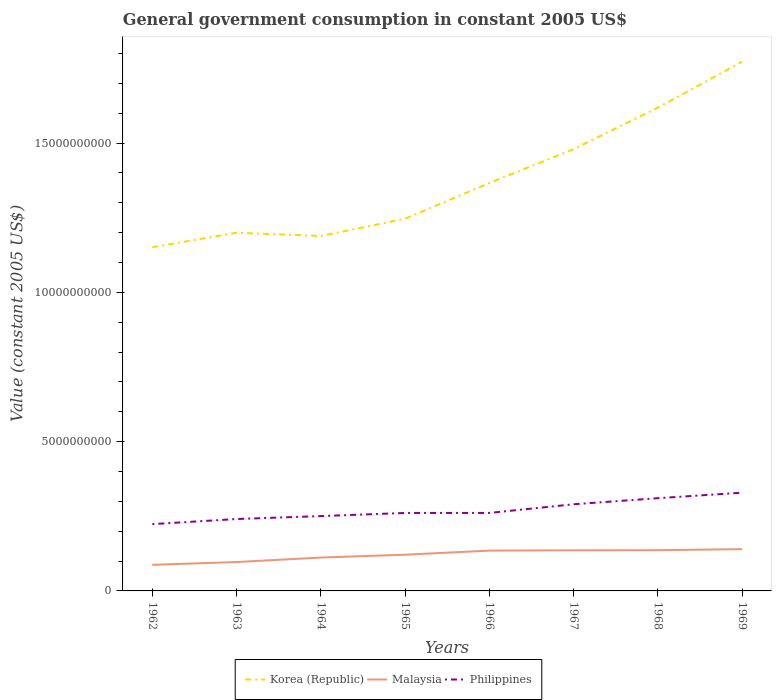How many different coloured lines are there?
Your response must be concise. 3. Is the number of lines equal to the number of legend labels?
Offer a very short reply. Yes. Across all years, what is the maximum government conusmption in Korea (Republic)?
Offer a terse response. 1.15e+1. What is the total government conusmption in Korea (Republic) in the graph?
Your response must be concise. -2.52e+09. What is the difference between the highest and the second highest government conusmption in Malaysia?
Provide a succinct answer. 5.26e+08. What is the difference between the highest and the lowest government conusmption in Korea (Republic)?
Make the answer very short. 3. How many years are there in the graph?
Make the answer very short. 8. What is the difference between two consecutive major ticks on the Y-axis?
Ensure brevity in your answer.  5.00e+09. Does the graph contain grids?
Provide a short and direct response. No. How many legend labels are there?
Ensure brevity in your answer.  3. What is the title of the graph?
Your answer should be compact. General government consumption in constant 2005 US$. What is the label or title of the X-axis?
Your response must be concise. Years. What is the label or title of the Y-axis?
Make the answer very short. Value (constant 2005 US$). What is the Value (constant 2005 US$) of Korea (Republic) in 1962?
Your answer should be compact. 1.15e+1. What is the Value (constant 2005 US$) of Malaysia in 1962?
Offer a very short reply. 8.74e+08. What is the Value (constant 2005 US$) in Philippines in 1962?
Your answer should be very brief. 2.24e+09. What is the Value (constant 2005 US$) of Korea (Republic) in 1963?
Give a very brief answer. 1.20e+1. What is the Value (constant 2005 US$) of Malaysia in 1963?
Offer a very short reply. 9.68e+08. What is the Value (constant 2005 US$) in Philippines in 1963?
Make the answer very short. 2.41e+09. What is the Value (constant 2005 US$) of Korea (Republic) in 1964?
Offer a terse response. 1.19e+1. What is the Value (constant 2005 US$) of Malaysia in 1964?
Provide a succinct answer. 1.12e+09. What is the Value (constant 2005 US$) in Philippines in 1964?
Make the answer very short. 2.51e+09. What is the Value (constant 2005 US$) of Korea (Republic) in 1965?
Your answer should be very brief. 1.25e+1. What is the Value (constant 2005 US$) in Malaysia in 1965?
Your answer should be compact. 1.21e+09. What is the Value (constant 2005 US$) in Philippines in 1965?
Provide a short and direct response. 2.61e+09. What is the Value (constant 2005 US$) in Korea (Republic) in 1966?
Your answer should be compact. 1.37e+1. What is the Value (constant 2005 US$) of Malaysia in 1966?
Offer a very short reply. 1.35e+09. What is the Value (constant 2005 US$) of Philippines in 1966?
Give a very brief answer. 2.61e+09. What is the Value (constant 2005 US$) in Korea (Republic) in 1967?
Provide a short and direct response. 1.48e+1. What is the Value (constant 2005 US$) of Malaysia in 1967?
Your answer should be very brief. 1.36e+09. What is the Value (constant 2005 US$) in Philippines in 1967?
Your answer should be compact. 2.90e+09. What is the Value (constant 2005 US$) of Korea (Republic) in 1968?
Your answer should be compact. 1.62e+1. What is the Value (constant 2005 US$) in Malaysia in 1968?
Give a very brief answer. 1.36e+09. What is the Value (constant 2005 US$) of Philippines in 1968?
Offer a very short reply. 3.11e+09. What is the Value (constant 2005 US$) in Korea (Republic) in 1969?
Keep it short and to the point. 1.77e+1. What is the Value (constant 2005 US$) of Malaysia in 1969?
Provide a short and direct response. 1.40e+09. What is the Value (constant 2005 US$) in Philippines in 1969?
Provide a short and direct response. 3.29e+09. Across all years, what is the maximum Value (constant 2005 US$) in Korea (Republic)?
Your answer should be compact. 1.77e+1. Across all years, what is the maximum Value (constant 2005 US$) of Malaysia?
Provide a succinct answer. 1.40e+09. Across all years, what is the maximum Value (constant 2005 US$) of Philippines?
Your response must be concise. 3.29e+09. Across all years, what is the minimum Value (constant 2005 US$) in Korea (Republic)?
Provide a succinct answer. 1.15e+1. Across all years, what is the minimum Value (constant 2005 US$) of Malaysia?
Offer a terse response. 8.74e+08. Across all years, what is the minimum Value (constant 2005 US$) of Philippines?
Keep it short and to the point. 2.24e+09. What is the total Value (constant 2005 US$) in Korea (Republic) in the graph?
Keep it short and to the point. 1.10e+11. What is the total Value (constant 2005 US$) in Malaysia in the graph?
Your answer should be very brief. 9.65e+09. What is the total Value (constant 2005 US$) in Philippines in the graph?
Your response must be concise. 2.17e+1. What is the difference between the Value (constant 2005 US$) of Korea (Republic) in 1962 and that in 1963?
Offer a terse response. -4.85e+08. What is the difference between the Value (constant 2005 US$) in Malaysia in 1962 and that in 1963?
Offer a very short reply. -9.39e+07. What is the difference between the Value (constant 2005 US$) in Philippines in 1962 and that in 1963?
Keep it short and to the point. -1.72e+08. What is the difference between the Value (constant 2005 US$) in Korea (Republic) in 1962 and that in 1964?
Your answer should be compact. -3.76e+08. What is the difference between the Value (constant 2005 US$) of Malaysia in 1962 and that in 1964?
Give a very brief answer. -2.44e+08. What is the difference between the Value (constant 2005 US$) of Philippines in 1962 and that in 1964?
Make the answer very short. -2.69e+08. What is the difference between the Value (constant 2005 US$) in Korea (Republic) in 1962 and that in 1965?
Make the answer very short. -9.53e+08. What is the difference between the Value (constant 2005 US$) in Malaysia in 1962 and that in 1965?
Provide a short and direct response. -3.39e+08. What is the difference between the Value (constant 2005 US$) of Philippines in 1962 and that in 1965?
Offer a terse response. -3.74e+08. What is the difference between the Value (constant 2005 US$) in Korea (Republic) in 1962 and that in 1966?
Provide a short and direct response. -2.15e+09. What is the difference between the Value (constant 2005 US$) of Malaysia in 1962 and that in 1966?
Offer a terse response. -4.76e+08. What is the difference between the Value (constant 2005 US$) of Philippines in 1962 and that in 1966?
Offer a terse response. -3.75e+08. What is the difference between the Value (constant 2005 US$) of Korea (Republic) in 1962 and that in 1967?
Keep it short and to the point. -3.28e+09. What is the difference between the Value (constant 2005 US$) in Malaysia in 1962 and that in 1967?
Give a very brief answer. -4.87e+08. What is the difference between the Value (constant 2005 US$) of Philippines in 1962 and that in 1967?
Offer a terse response. -6.65e+08. What is the difference between the Value (constant 2005 US$) in Korea (Republic) in 1962 and that in 1968?
Provide a succinct answer. -4.67e+09. What is the difference between the Value (constant 2005 US$) of Malaysia in 1962 and that in 1968?
Make the answer very short. -4.90e+08. What is the difference between the Value (constant 2005 US$) in Philippines in 1962 and that in 1968?
Your answer should be compact. -8.69e+08. What is the difference between the Value (constant 2005 US$) of Korea (Republic) in 1962 and that in 1969?
Ensure brevity in your answer.  -6.21e+09. What is the difference between the Value (constant 2005 US$) of Malaysia in 1962 and that in 1969?
Keep it short and to the point. -5.26e+08. What is the difference between the Value (constant 2005 US$) of Philippines in 1962 and that in 1969?
Ensure brevity in your answer.  -1.05e+09. What is the difference between the Value (constant 2005 US$) in Korea (Republic) in 1963 and that in 1964?
Provide a short and direct response. 1.09e+08. What is the difference between the Value (constant 2005 US$) in Malaysia in 1963 and that in 1964?
Your answer should be very brief. -1.50e+08. What is the difference between the Value (constant 2005 US$) of Philippines in 1963 and that in 1964?
Give a very brief answer. -9.80e+07. What is the difference between the Value (constant 2005 US$) of Korea (Republic) in 1963 and that in 1965?
Keep it short and to the point. -4.68e+08. What is the difference between the Value (constant 2005 US$) of Malaysia in 1963 and that in 1965?
Your answer should be compact. -2.45e+08. What is the difference between the Value (constant 2005 US$) in Philippines in 1963 and that in 1965?
Provide a succinct answer. -2.03e+08. What is the difference between the Value (constant 2005 US$) in Korea (Republic) in 1963 and that in 1966?
Make the answer very short. -1.67e+09. What is the difference between the Value (constant 2005 US$) in Malaysia in 1963 and that in 1966?
Offer a terse response. -3.83e+08. What is the difference between the Value (constant 2005 US$) in Philippines in 1963 and that in 1966?
Provide a succinct answer. -2.04e+08. What is the difference between the Value (constant 2005 US$) in Korea (Republic) in 1963 and that in 1967?
Your answer should be very brief. -2.80e+09. What is the difference between the Value (constant 2005 US$) in Malaysia in 1963 and that in 1967?
Provide a succinct answer. -3.93e+08. What is the difference between the Value (constant 2005 US$) of Philippines in 1963 and that in 1967?
Ensure brevity in your answer.  -4.94e+08. What is the difference between the Value (constant 2005 US$) of Korea (Republic) in 1963 and that in 1968?
Your answer should be very brief. -4.19e+09. What is the difference between the Value (constant 2005 US$) of Malaysia in 1963 and that in 1968?
Your answer should be compact. -3.96e+08. What is the difference between the Value (constant 2005 US$) of Philippines in 1963 and that in 1968?
Offer a terse response. -6.97e+08. What is the difference between the Value (constant 2005 US$) in Korea (Republic) in 1963 and that in 1969?
Provide a succinct answer. -5.73e+09. What is the difference between the Value (constant 2005 US$) in Malaysia in 1963 and that in 1969?
Ensure brevity in your answer.  -4.32e+08. What is the difference between the Value (constant 2005 US$) of Philippines in 1963 and that in 1969?
Offer a terse response. -8.82e+08. What is the difference between the Value (constant 2005 US$) in Korea (Republic) in 1964 and that in 1965?
Your response must be concise. -5.77e+08. What is the difference between the Value (constant 2005 US$) in Malaysia in 1964 and that in 1965?
Provide a succinct answer. -9.55e+07. What is the difference between the Value (constant 2005 US$) in Philippines in 1964 and that in 1965?
Offer a very short reply. -1.05e+08. What is the difference between the Value (constant 2005 US$) of Korea (Republic) in 1964 and that in 1966?
Provide a succinct answer. -1.77e+09. What is the difference between the Value (constant 2005 US$) of Malaysia in 1964 and that in 1966?
Keep it short and to the point. -2.33e+08. What is the difference between the Value (constant 2005 US$) in Philippines in 1964 and that in 1966?
Provide a succinct answer. -1.06e+08. What is the difference between the Value (constant 2005 US$) in Korea (Republic) in 1964 and that in 1967?
Your response must be concise. -2.91e+09. What is the difference between the Value (constant 2005 US$) in Malaysia in 1964 and that in 1967?
Your answer should be compact. -2.43e+08. What is the difference between the Value (constant 2005 US$) in Philippines in 1964 and that in 1967?
Your answer should be very brief. -3.96e+08. What is the difference between the Value (constant 2005 US$) in Korea (Republic) in 1964 and that in 1968?
Ensure brevity in your answer.  -4.30e+09. What is the difference between the Value (constant 2005 US$) in Malaysia in 1964 and that in 1968?
Keep it short and to the point. -2.46e+08. What is the difference between the Value (constant 2005 US$) of Philippines in 1964 and that in 1968?
Give a very brief answer. -5.99e+08. What is the difference between the Value (constant 2005 US$) of Korea (Republic) in 1964 and that in 1969?
Your response must be concise. -5.84e+09. What is the difference between the Value (constant 2005 US$) in Malaysia in 1964 and that in 1969?
Your answer should be very brief. -2.82e+08. What is the difference between the Value (constant 2005 US$) of Philippines in 1964 and that in 1969?
Make the answer very short. -7.84e+08. What is the difference between the Value (constant 2005 US$) in Korea (Republic) in 1965 and that in 1966?
Make the answer very short. -1.20e+09. What is the difference between the Value (constant 2005 US$) in Malaysia in 1965 and that in 1966?
Your answer should be compact. -1.37e+08. What is the difference between the Value (constant 2005 US$) of Philippines in 1965 and that in 1966?
Offer a very short reply. -8.17e+05. What is the difference between the Value (constant 2005 US$) in Korea (Republic) in 1965 and that in 1967?
Provide a short and direct response. -2.33e+09. What is the difference between the Value (constant 2005 US$) in Malaysia in 1965 and that in 1967?
Your answer should be very brief. -1.47e+08. What is the difference between the Value (constant 2005 US$) in Philippines in 1965 and that in 1967?
Provide a short and direct response. -2.91e+08. What is the difference between the Value (constant 2005 US$) in Korea (Republic) in 1965 and that in 1968?
Give a very brief answer. -3.72e+09. What is the difference between the Value (constant 2005 US$) of Malaysia in 1965 and that in 1968?
Your answer should be compact. -1.50e+08. What is the difference between the Value (constant 2005 US$) in Philippines in 1965 and that in 1968?
Keep it short and to the point. -4.95e+08. What is the difference between the Value (constant 2005 US$) of Korea (Republic) in 1965 and that in 1969?
Keep it short and to the point. -5.26e+09. What is the difference between the Value (constant 2005 US$) in Malaysia in 1965 and that in 1969?
Your response must be concise. -1.87e+08. What is the difference between the Value (constant 2005 US$) of Philippines in 1965 and that in 1969?
Your answer should be compact. -6.79e+08. What is the difference between the Value (constant 2005 US$) in Korea (Republic) in 1966 and that in 1967?
Ensure brevity in your answer.  -1.13e+09. What is the difference between the Value (constant 2005 US$) of Malaysia in 1966 and that in 1967?
Ensure brevity in your answer.  -1.01e+07. What is the difference between the Value (constant 2005 US$) of Philippines in 1966 and that in 1967?
Your answer should be very brief. -2.90e+08. What is the difference between the Value (constant 2005 US$) of Korea (Republic) in 1966 and that in 1968?
Give a very brief answer. -2.52e+09. What is the difference between the Value (constant 2005 US$) of Malaysia in 1966 and that in 1968?
Your response must be concise. -1.33e+07. What is the difference between the Value (constant 2005 US$) of Philippines in 1966 and that in 1968?
Your answer should be very brief. -4.94e+08. What is the difference between the Value (constant 2005 US$) in Korea (Republic) in 1966 and that in 1969?
Your answer should be compact. -4.06e+09. What is the difference between the Value (constant 2005 US$) in Malaysia in 1966 and that in 1969?
Give a very brief answer. -4.96e+07. What is the difference between the Value (constant 2005 US$) in Philippines in 1966 and that in 1969?
Your answer should be compact. -6.78e+08. What is the difference between the Value (constant 2005 US$) in Korea (Republic) in 1967 and that in 1968?
Offer a very short reply. -1.39e+09. What is the difference between the Value (constant 2005 US$) in Malaysia in 1967 and that in 1968?
Your answer should be very brief. -3.20e+06. What is the difference between the Value (constant 2005 US$) of Philippines in 1967 and that in 1968?
Offer a terse response. -2.04e+08. What is the difference between the Value (constant 2005 US$) of Korea (Republic) in 1967 and that in 1969?
Give a very brief answer. -2.93e+09. What is the difference between the Value (constant 2005 US$) of Malaysia in 1967 and that in 1969?
Your response must be concise. -3.95e+07. What is the difference between the Value (constant 2005 US$) in Philippines in 1967 and that in 1969?
Your answer should be compact. -3.88e+08. What is the difference between the Value (constant 2005 US$) in Korea (Republic) in 1968 and that in 1969?
Provide a succinct answer. -1.54e+09. What is the difference between the Value (constant 2005 US$) in Malaysia in 1968 and that in 1969?
Offer a terse response. -3.63e+07. What is the difference between the Value (constant 2005 US$) of Philippines in 1968 and that in 1969?
Your response must be concise. -1.85e+08. What is the difference between the Value (constant 2005 US$) in Korea (Republic) in 1962 and the Value (constant 2005 US$) in Malaysia in 1963?
Offer a terse response. 1.05e+1. What is the difference between the Value (constant 2005 US$) in Korea (Republic) in 1962 and the Value (constant 2005 US$) in Philippines in 1963?
Offer a very short reply. 9.10e+09. What is the difference between the Value (constant 2005 US$) in Malaysia in 1962 and the Value (constant 2005 US$) in Philippines in 1963?
Give a very brief answer. -1.53e+09. What is the difference between the Value (constant 2005 US$) in Korea (Republic) in 1962 and the Value (constant 2005 US$) in Malaysia in 1964?
Offer a terse response. 1.04e+1. What is the difference between the Value (constant 2005 US$) in Korea (Republic) in 1962 and the Value (constant 2005 US$) in Philippines in 1964?
Offer a terse response. 9.01e+09. What is the difference between the Value (constant 2005 US$) in Malaysia in 1962 and the Value (constant 2005 US$) in Philippines in 1964?
Your answer should be very brief. -1.63e+09. What is the difference between the Value (constant 2005 US$) of Korea (Republic) in 1962 and the Value (constant 2005 US$) of Malaysia in 1965?
Your response must be concise. 1.03e+1. What is the difference between the Value (constant 2005 US$) of Korea (Republic) in 1962 and the Value (constant 2005 US$) of Philippines in 1965?
Your answer should be very brief. 8.90e+09. What is the difference between the Value (constant 2005 US$) in Malaysia in 1962 and the Value (constant 2005 US$) in Philippines in 1965?
Offer a very short reply. -1.74e+09. What is the difference between the Value (constant 2005 US$) in Korea (Republic) in 1962 and the Value (constant 2005 US$) in Malaysia in 1966?
Offer a very short reply. 1.02e+1. What is the difference between the Value (constant 2005 US$) of Korea (Republic) in 1962 and the Value (constant 2005 US$) of Philippines in 1966?
Provide a succinct answer. 8.90e+09. What is the difference between the Value (constant 2005 US$) of Malaysia in 1962 and the Value (constant 2005 US$) of Philippines in 1966?
Provide a succinct answer. -1.74e+09. What is the difference between the Value (constant 2005 US$) in Korea (Republic) in 1962 and the Value (constant 2005 US$) in Malaysia in 1967?
Provide a short and direct response. 1.02e+1. What is the difference between the Value (constant 2005 US$) in Korea (Republic) in 1962 and the Value (constant 2005 US$) in Philippines in 1967?
Ensure brevity in your answer.  8.61e+09. What is the difference between the Value (constant 2005 US$) in Malaysia in 1962 and the Value (constant 2005 US$) in Philippines in 1967?
Offer a terse response. -2.03e+09. What is the difference between the Value (constant 2005 US$) of Korea (Republic) in 1962 and the Value (constant 2005 US$) of Malaysia in 1968?
Offer a terse response. 1.01e+1. What is the difference between the Value (constant 2005 US$) of Korea (Republic) in 1962 and the Value (constant 2005 US$) of Philippines in 1968?
Provide a short and direct response. 8.41e+09. What is the difference between the Value (constant 2005 US$) of Malaysia in 1962 and the Value (constant 2005 US$) of Philippines in 1968?
Your answer should be very brief. -2.23e+09. What is the difference between the Value (constant 2005 US$) in Korea (Republic) in 1962 and the Value (constant 2005 US$) in Malaysia in 1969?
Ensure brevity in your answer.  1.01e+1. What is the difference between the Value (constant 2005 US$) of Korea (Republic) in 1962 and the Value (constant 2005 US$) of Philippines in 1969?
Offer a very short reply. 8.22e+09. What is the difference between the Value (constant 2005 US$) in Malaysia in 1962 and the Value (constant 2005 US$) in Philippines in 1969?
Keep it short and to the point. -2.42e+09. What is the difference between the Value (constant 2005 US$) in Korea (Republic) in 1963 and the Value (constant 2005 US$) in Malaysia in 1964?
Offer a very short reply. 1.09e+1. What is the difference between the Value (constant 2005 US$) of Korea (Republic) in 1963 and the Value (constant 2005 US$) of Philippines in 1964?
Provide a short and direct response. 9.49e+09. What is the difference between the Value (constant 2005 US$) of Malaysia in 1963 and the Value (constant 2005 US$) of Philippines in 1964?
Your response must be concise. -1.54e+09. What is the difference between the Value (constant 2005 US$) in Korea (Republic) in 1963 and the Value (constant 2005 US$) in Malaysia in 1965?
Your answer should be very brief. 1.08e+1. What is the difference between the Value (constant 2005 US$) of Korea (Republic) in 1963 and the Value (constant 2005 US$) of Philippines in 1965?
Give a very brief answer. 9.39e+09. What is the difference between the Value (constant 2005 US$) of Malaysia in 1963 and the Value (constant 2005 US$) of Philippines in 1965?
Keep it short and to the point. -1.64e+09. What is the difference between the Value (constant 2005 US$) in Korea (Republic) in 1963 and the Value (constant 2005 US$) in Malaysia in 1966?
Give a very brief answer. 1.06e+1. What is the difference between the Value (constant 2005 US$) in Korea (Republic) in 1963 and the Value (constant 2005 US$) in Philippines in 1966?
Your response must be concise. 9.39e+09. What is the difference between the Value (constant 2005 US$) of Malaysia in 1963 and the Value (constant 2005 US$) of Philippines in 1966?
Keep it short and to the point. -1.64e+09. What is the difference between the Value (constant 2005 US$) of Korea (Republic) in 1963 and the Value (constant 2005 US$) of Malaysia in 1967?
Your answer should be very brief. 1.06e+1. What is the difference between the Value (constant 2005 US$) in Korea (Republic) in 1963 and the Value (constant 2005 US$) in Philippines in 1967?
Your answer should be compact. 9.10e+09. What is the difference between the Value (constant 2005 US$) in Malaysia in 1963 and the Value (constant 2005 US$) in Philippines in 1967?
Make the answer very short. -1.93e+09. What is the difference between the Value (constant 2005 US$) in Korea (Republic) in 1963 and the Value (constant 2005 US$) in Malaysia in 1968?
Keep it short and to the point. 1.06e+1. What is the difference between the Value (constant 2005 US$) of Korea (Republic) in 1963 and the Value (constant 2005 US$) of Philippines in 1968?
Ensure brevity in your answer.  8.89e+09. What is the difference between the Value (constant 2005 US$) of Malaysia in 1963 and the Value (constant 2005 US$) of Philippines in 1968?
Your response must be concise. -2.14e+09. What is the difference between the Value (constant 2005 US$) in Korea (Republic) in 1963 and the Value (constant 2005 US$) in Malaysia in 1969?
Your response must be concise. 1.06e+1. What is the difference between the Value (constant 2005 US$) in Korea (Republic) in 1963 and the Value (constant 2005 US$) in Philippines in 1969?
Offer a very short reply. 8.71e+09. What is the difference between the Value (constant 2005 US$) in Malaysia in 1963 and the Value (constant 2005 US$) in Philippines in 1969?
Offer a terse response. -2.32e+09. What is the difference between the Value (constant 2005 US$) of Korea (Republic) in 1964 and the Value (constant 2005 US$) of Malaysia in 1965?
Your answer should be very brief. 1.07e+1. What is the difference between the Value (constant 2005 US$) in Korea (Republic) in 1964 and the Value (constant 2005 US$) in Philippines in 1965?
Your response must be concise. 9.28e+09. What is the difference between the Value (constant 2005 US$) of Malaysia in 1964 and the Value (constant 2005 US$) of Philippines in 1965?
Your answer should be very brief. -1.49e+09. What is the difference between the Value (constant 2005 US$) of Korea (Republic) in 1964 and the Value (constant 2005 US$) of Malaysia in 1966?
Ensure brevity in your answer.  1.05e+1. What is the difference between the Value (constant 2005 US$) of Korea (Republic) in 1964 and the Value (constant 2005 US$) of Philippines in 1966?
Provide a succinct answer. 9.28e+09. What is the difference between the Value (constant 2005 US$) of Malaysia in 1964 and the Value (constant 2005 US$) of Philippines in 1966?
Your answer should be very brief. -1.49e+09. What is the difference between the Value (constant 2005 US$) of Korea (Republic) in 1964 and the Value (constant 2005 US$) of Malaysia in 1967?
Your answer should be very brief. 1.05e+1. What is the difference between the Value (constant 2005 US$) in Korea (Republic) in 1964 and the Value (constant 2005 US$) in Philippines in 1967?
Offer a very short reply. 8.99e+09. What is the difference between the Value (constant 2005 US$) in Malaysia in 1964 and the Value (constant 2005 US$) in Philippines in 1967?
Make the answer very short. -1.78e+09. What is the difference between the Value (constant 2005 US$) of Korea (Republic) in 1964 and the Value (constant 2005 US$) of Malaysia in 1968?
Your response must be concise. 1.05e+1. What is the difference between the Value (constant 2005 US$) of Korea (Republic) in 1964 and the Value (constant 2005 US$) of Philippines in 1968?
Your answer should be very brief. 8.78e+09. What is the difference between the Value (constant 2005 US$) of Malaysia in 1964 and the Value (constant 2005 US$) of Philippines in 1968?
Offer a very short reply. -1.99e+09. What is the difference between the Value (constant 2005 US$) in Korea (Republic) in 1964 and the Value (constant 2005 US$) in Malaysia in 1969?
Keep it short and to the point. 1.05e+1. What is the difference between the Value (constant 2005 US$) of Korea (Republic) in 1964 and the Value (constant 2005 US$) of Philippines in 1969?
Make the answer very short. 8.60e+09. What is the difference between the Value (constant 2005 US$) in Malaysia in 1964 and the Value (constant 2005 US$) in Philippines in 1969?
Give a very brief answer. -2.17e+09. What is the difference between the Value (constant 2005 US$) in Korea (Republic) in 1965 and the Value (constant 2005 US$) in Malaysia in 1966?
Your answer should be very brief. 1.11e+1. What is the difference between the Value (constant 2005 US$) in Korea (Republic) in 1965 and the Value (constant 2005 US$) in Philippines in 1966?
Your answer should be very brief. 9.85e+09. What is the difference between the Value (constant 2005 US$) of Malaysia in 1965 and the Value (constant 2005 US$) of Philippines in 1966?
Offer a very short reply. -1.40e+09. What is the difference between the Value (constant 2005 US$) of Korea (Republic) in 1965 and the Value (constant 2005 US$) of Malaysia in 1967?
Your answer should be compact. 1.11e+1. What is the difference between the Value (constant 2005 US$) of Korea (Republic) in 1965 and the Value (constant 2005 US$) of Philippines in 1967?
Provide a short and direct response. 9.56e+09. What is the difference between the Value (constant 2005 US$) of Malaysia in 1965 and the Value (constant 2005 US$) of Philippines in 1967?
Your response must be concise. -1.69e+09. What is the difference between the Value (constant 2005 US$) in Korea (Republic) in 1965 and the Value (constant 2005 US$) in Malaysia in 1968?
Provide a succinct answer. 1.11e+1. What is the difference between the Value (constant 2005 US$) of Korea (Republic) in 1965 and the Value (constant 2005 US$) of Philippines in 1968?
Ensure brevity in your answer.  9.36e+09. What is the difference between the Value (constant 2005 US$) of Malaysia in 1965 and the Value (constant 2005 US$) of Philippines in 1968?
Your response must be concise. -1.89e+09. What is the difference between the Value (constant 2005 US$) of Korea (Republic) in 1965 and the Value (constant 2005 US$) of Malaysia in 1969?
Offer a terse response. 1.11e+1. What is the difference between the Value (constant 2005 US$) in Korea (Republic) in 1965 and the Value (constant 2005 US$) in Philippines in 1969?
Offer a very short reply. 9.18e+09. What is the difference between the Value (constant 2005 US$) in Malaysia in 1965 and the Value (constant 2005 US$) in Philippines in 1969?
Provide a succinct answer. -2.08e+09. What is the difference between the Value (constant 2005 US$) in Korea (Republic) in 1966 and the Value (constant 2005 US$) in Malaysia in 1967?
Your response must be concise. 1.23e+1. What is the difference between the Value (constant 2005 US$) in Korea (Republic) in 1966 and the Value (constant 2005 US$) in Philippines in 1967?
Ensure brevity in your answer.  1.08e+1. What is the difference between the Value (constant 2005 US$) in Malaysia in 1966 and the Value (constant 2005 US$) in Philippines in 1967?
Offer a very short reply. -1.55e+09. What is the difference between the Value (constant 2005 US$) in Korea (Republic) in 1966 and the Value (constant 2005 US$) in Malaysia in 1968?
Make the answer very short. 1.23e+1. What is the difference between the Value (constant 2005 US$) in Korea (Republic) in 1966 and the Value (constant 2005 US$) in Philippines in 1968?
Keep it short and to the point. 1.06e+1. What is the difference between the Value (constant 2005 US$) of Malaysia in 1966 and the Value (constant 2005 US$) of Philippines in 1968?
Your answer should be compact. -1.76e+09. What is the difference between the Value (constant 2005 US$) of Korea (Republic) in 1966 and the Value (constant 2005 US$) of Malaysia in 1969?
Make the answer very short. 1.23e+1. What is the difference between the Value (constant 2005 US$) of Korea (Republic) in 1966 and the Value (constant 2005 US$) of Philippines in 1969?
Make the answer very short. 1.04e+1. What is the difference between the Value (constant 2005 US$) of Malaysia in 1966 and the Value (constant 2005 US$) of Philippines in 1969?
Offer a terse response. -1.94e+09. What is the difference between the Value (constant 2005 US$) in Korea (Republic) in 1967 and the Value (constant 2005 US$) in Malaysia in 1968?
Keep it short and to the point. 1.34e+1. What is the difference between the Value (constant 2005 US$) in Korea (Republic) in 1967 and the Value (constant 2005 US$) in Philippines in 1968?
Keep it short and to the point. 1.17e+1. What is the difference between the Value (constant 2005 US$) in Malaysia in 1967 and the Value (constant 2005 US$) in Philippines in 1968?
Provide a short and direct response. -1.75e+09. What is the difference between the Value (constant 2005 US$) in Korea (Republic) in 1967 and the Value (constant 2005 US$) in Malaysia in 1969?
Your response must be concise. 1.34e+1. What is the difference between the Value (constant 2005 US$) in Korea (Republic) in 1967 and the Value (constant 2005 US$) in Philippines in 1969?
Your response must be concise. 1.15e+1. What is the difference between the Value (constant 2005 US$) of Malaysia in 1967 and the Value (constant 2005 US$) of Philippines in 1969?
Provide a succinct answer. -1.93e+09. What is the difference between the Value (constant 2005 US$) in Korea (Republic) in 1968 and the Value (constant 2005 US$) in Malaysia in 1969?
Provide a short and direct response. 1.48e+1. What is the difference between the Value (constant 2005 US$) of Korea (Republic) in 1968 and the Value (constant 2005 US$) of Philippines in 1969?
Give a very brief answer. 1.29e+1. What is the difference between the Value (constant 2005 US$) in Malaysia in 1968 and the Value (constant 2005 US$) in Philippines in 1969?
Keep it short and to the point. -1.93e+09. What is the average Value (constant 2005 US$) of Korea (Republic) per year?
Ensure brevity in your answer.  1.38e+1. What is the average Value (constant 2005 US$) in Malaysia per year?
Offer a terse response. 1.21e+09. What is the average Value (constant 2005 US$) of Philippines per year?
Keep it short and to the point. 2.71e+09. In the year 1962, what is the difference between the Value (constant 2005 US$) in Korea (Republic) and Value (constant 2005 US$) in Malaysia?
Your answer should be very brief. 1.06e+1. In the year 1962, what is the difference between the Value (constant 2005 US$) of Korea (Republic) and Value (constant 2005 US$) of Philippines?
Keep it short and to the point. 9.28e+09. In the year 1962, what is the difference between the Value (constant 2005 US$) of Malaysia and Value (constant 2005 US$) of Philippines?
Your answer should be very brief. -1.36e+09. In the year 1963, what is the difference between the Value (constant 2005 US$) in Korea (Republic) and Value (constant 2005 US$) in Malaysia?
Your answer should be very brief. 1.10e+1. In the year 1963, what is the difference between the Value (constant 2005 US$) of Korea (Republic) and Value (constant 2005 US$) of Philippines?
Ensure brevity in your answer.  9.59e+09. In the year 1963, what is the difference between the Value (constant 2005 US$) of Malaysia and Value (constant 2005 US$) of Philippines?
Offer a terse response. -1.44e+09. In the year 1964, what is the difference between the Value (constant 2005 US$) of Korea (Republic) and Value (constant 2005 US$) of Malaysia?
Provide a short and direct response. 1.08e+1. In the year 1964, what is the difference between the Value (constant 2005 US$) of Korea (Republic) and Value (constant 2005 US$) of Philippines?
Your response must be concise. 9.38e+09. In the year 1964, what is the difference between the Value (constant 2005 US$) of Malaysia and Value (constant 2005 US$) of Philippines?
Ensure brevity in your answer.  -1.39e+09. In the year 1965, what is the difference between the Value (constant 2005 US$) in Korea (Republic) and Value (constant 2005 US$) in Malaysia?
Keep it short and to the point. 1.13e+1. In the year 1965, what is the difference between the Value (constant 2005 US$) in Korea (Republic) and Value (constant 2005 US$) in Philippines?
Make the answer very short. 9.85e+09. In the year 1965, what is the difference between the Value (constant 2005 US$) of Malaysia and Value (constant 2005 US$) of Philippines?
Ensure brevity in your answer.  -1.40e+09. In the year 1966, what is the difference between the Value (constant 2005 US$) of Korea (Republic) and Value (constant 2005 US$) of Malaysia?
Give a very brief answer. 1.23e+1. In the year 1966, what is the difference between the Value (constant 2005 US$) in Korea (Republic) and Value (constant 2005 US$) in Philippines?
Provide a short and direct response. 1.11e+1. In the year 1966, what is the difference between the Value (constant 2005 US$) in Malaysia and Value (constant 2005 US$) in Philippines?
Keep it short and to the point. -1.26e+09. In the year 1967, what is the difference between the Value (constant 2005 US$) of Korea (Republic) and Value (constant 2005 US$) of Malaysia?
Your response must be concise. 1.34e+1. In the year 1967, what is the difference between the Value (constant 2005 US$) in Korea (Republic) and Value (constant 2005 US$) in Philippines?
Make the answer very short. 1.19e+1. In the year 1967, what is the difference between the Value (constant 2005 US$) of Malaysia and Value (constant 2005 US$) of Philippines?
Provide a short and direct response. -1.54e+09. In the year 1968, what is the difference between the Value (constant 2005 US$) in Korea (Republic) and Value (constant 2005 US$) in Malaysia?
Offer a very short reply. 1.48e+1. In the year 1968, what is the difference between the Value (constant 2005 US$) of Korea (Republic) and Value (constant 2005 US$) of Philippines?
Provide a short and direct response. 1.31e+1. In the year 1968, what is the difference between the Value (constant 2005 US$) in Malaysia and Value (constant 2005 US$) in Philippines?
Provide a short and direct response. -1.74e+09. In the year 1969, what is the difference between the Value (constant 2005 US$) of Korea (Republic) and Value (constant 2005 US$) of Malaysia?
Provide a succinct answer. 1.63e+1. In the year 1969, what is the difference between the Value (constant 2005 US$) in Korea (Republic) and Value (constant 2005 US$) in Philippines?
Provide a short and direct response. 1.44e+1. In the year 1969, what is the difference between the Value (constant 2005 US$) in Malaysia and Value (constant 2005 US$) in Philippines?
Your response must be concise. -1.89e+09. What is the ratio of the Value (constant 2005 US$) in Korea (Republic) in 1962 to that in 1963?
Your answer should be compact. 0.96. What is the ratio of the Value (constant 2005 US$) of Malaysia in 1962 to that in 1963?
Give a very brief answer. 0.9. What is the ratio of the Value (constant 2005 US$) in Philippines in 1962 to that in 1963?
Offer a very short reply. 0.93. What is the ratio of the Value (constant 2005 US$) of Korea (Republic) in 1962 to that in 1964?
Offer a very short reply. 0.97. What is the ratio of the Value (constant 2005 US$) of Malaysia in 1962 to that in 1964?
Provide a succinct answer. 0.78. What is the ratio of the Value (constant 2005 US$) in Philippines in 1962 to that in 1964?
Make the answer very short. 0.89. What is the ratio of the Value (constant 2005 US$) of Korea (Republic) in 1962 to that in 1965?
Offer a very short reply. 0.92. What is the ratio of the Value (constant 2005 US$) of Malaysia in 1962 to that in 1965?
Your answer should be very brief. 0.72. What is the ratio of the Value (constant 2005 US$) of Philippines in 1962 to that in 1965?
Make the answer very short. 0.86. What is the ratio of the Value (constant 2005 US$) in Korea (Republic) in 1962 to that in 1966?
Provide a succinct answer. 0.84. What is the ratio of the Value (constant 2005 US$) in Malaysia in 1962 to that in 1966?
Your answer should be very brief. 0.65. What is the ratio of the Value (constant 2005 US$) in Philippines in 1962 to that in 1966?
Your response must be concise. 0.86. What is the ratio of the Value (constant 2005 US$) in Korea (Republic) in 1962 to that in 1967?
Give a very brief answer. 0.78. What is the ratio of the Value (constant 2005 US$) in Malaysia in 1962 to that in 1967?
Keep it short and to the point. 0.64. What is the ratio of the Value (constant 2005 US$) of Philippines in 1962 to that in 1967?
Your answer should be very brief. 0.77. What is the ratio of the Value (constant 2005 US$) of Korea (Republic) in 1962 to that in 1968?
Offer a terse response. 0.71. What is the ratio of the Value (constant 2005 US$) of Malaysia in 1962 to that in 1968?
Provide a succinct answer. 0.64. What is the ratio of the Value (constant 2005 US$) of Philippines in 1962 to that in 1968?
Your answer should be very brief. 0.72. What is the ratio of the Value (constant 2005 US$) of Korea (Republic) in 1962 to that in 1969?
Your answer should be compact. 0.65. What is the ratio of the Value (constant 2005 US$) of Malaysia in 1962 to that in 1969?
Ensure brevity in your answer.  0.62. What is the ratio of the Value (constant 2005 US$) in Philippines in 1962 to that in 1969?
Offer a very short reply. 0.68. What is the ratio of the Value (constant 2005 US$) in Korea (Republic) in 1963 to that in 1964?
Your response must be concise. 1.01. What is the ratio of the Value (constant 2005 US$) in Malaysia in 1963 to that in 1964?
Your response must be concise. 0.87. What is the ratio of the Value (constant 2005 US$) in Philippines in 1963 to that in 1964?
Give a very brief answer. 0.96. What is the ratio of the Value (constant 2005 US$) in Korea (Republic) in 1963 to that in 1965?
Provide a short and direct response. 0.96. What is the ratio of the Value (constant 2005 US$) of Malaysia in 1963 to that in 1965?
Your answer should be compact. 0.8. What is the ratio of the Value (constant 2005 US$) of Philippines in 1963 to that in 1965?
Give a very brief answer. 0.92. What is the ratio of the Value (constant 2005 US$) in Korea (Republic) in 1963 to that in 1966?
Offer a very short reply. 0.88. What is the ratio of the Value (constant 2005 US$) of Malaysia in 1963 to that in 1966?
Offer a terse response. 0.72. What is the ratio of the Value (constant 2005 US$) in Philippines in 1963 to that in 1966?
Your response must be concise. 0.92. What is the ratio of the Value (constant 2005 US$) of Korea (Republic) in 1963 to that in 1967?
Your answer should be compact. 0.81. What is the ratio of the Value (constant 2005 US$) in Malaysia in 1963 to that in 1967?
Your answer should be very brief. 0.71. What is the ratio of the Value (constant 2005 US$) of Philippines in 1963 to that in 1967?
Provide a succinct answer. 0.83. What is the ratio of the Value (constant 2005 US$) in Korea (Republic) in 1963 to that in 1968?
Your answer should be compact. 0.74. What is the ratio of the Value (constant 2005 US$) of Malaysia in 1963 to that in 1968?
Offer a terse response. 0.71. What is the ratio of the Value (constant 2005 US$) in Philippines in 1963 to that in 1968?
Your response must be concise. 0.78. What is the ratio of the Value (constant 2005 US$) of Korea (Republic) in 1963 to that in 1969?
Keep it short and to the point. 0.68. What is the ratio of the Value (constant 2005 US$) in Malaysia in 1963 to that in 1969?
Your response must be concise. 0.69. What is the ratio of the Value (constant 2005 US$) in Philippines in 1963 to that in 1969?
Give a very brief answer. 0.73. What is the ratio of the Value (constant 2005 US$) in Korea (Republic) in 1964 to that in 1965?
Give a very brief answer. 0.95. What is the ratio of the Value (constant 2005 US$) in Malaysia in 1964 to that in 1965?
Offer a terse response. 0.92. What is the ratio of the Value (constant 2005 US$) in Philippines in 1964 to that in 1965?
Your response must be concise. 0.96. What is the ratio of the Value (constant 2005 US$) of Korea (Republic) in 1964 to that in 1966?
Ensure brevity in your answer.  0.87. What is the ratio of the Value (constant 2005 US$) in Malaysia in 1964 to that in 1966?
Make the answer very short. 0.83. What is the ratio of the Value (constant 2005 US$) of Philippines in 1964 to that in 1966?
Provide a short and direct response. 0.96. What is the ratio of the Value (constant 2005 US$) of Korea (Republic) in 1964 to that in 1967?
Give a very brief answer. 0.8. What is the ratio of the Value (constant 2005 US$) in Malaysia in 1964 to that in 1967?
Offer a very short reply. 0.82. What is the ratio of the Value (constant 2005 US$) in Philippines in 1964 to that in 1967?
Provide a succinct answer. 0.86. What is the ratio of the Value (constant 2005 US$) of Korea (Republic) in 1964 to that in 1968?
Offer a terse response. 0.73. What is the ratio of the Value (constant 2005 US$) in Malaysia in 1964 to that in 1968?
Your answer should be compact. 0.82. What is the ratio of the Value (constant 2005 US$) in Philippines in 1964 to that in 1968?
Ensure brevity in your answer.  0.81. What is the ratio of the Value (constant 2005 US$) in Korea (Republic) in 1964 to that in 1969?
Your response must be concise. 0.67. What is the ratio of the Value (constant 2005 US$) of Malaysia in 1964 to that in 1969?
Give a very brief answer. 0.8. What is the ratio of the Value (constant 2005 US$) of Philippines in 1964 to that in 1969?
Provide a short and direct response. 0.76. What is the ratio of the Value (constant 2005 US$) of Korea (Republic) in 1965 to that in 1966?
Offer a very short reply. 0.91. What is the ratio of the Value (constant 2005 US$) of Malaysia in 1965 to that in 1966?
Provide a succinct answer. 0.9. What is the ratio of the Value (constant 2005 US$) of Korea (Republic) in 1965 to that in 1967?
Give a very brief answer. 0.84. What is the ratio of the Value (constant 2005 US$) in Malaysia in 1965 to that in 1967?
Ensure brevity in your answer.  0.89. What is the ratio of the Value (constant 2005 US$) in Philippines in 1965 to that in 1967?
Your answer should be very brief. 0.9. What is the ratio of the Value (constant 2005 US$) of Korea (Republic) in 1965 to that in 1968?
Give a very brief answer. 0.77. What is the ratio of the Value (constant 2005 US$) of Malaysia in 1965 to that in 1968?
Provide a short and direct response. 0.89. What is the ratio of the Value (constant 2005 US$) in Philippines in 1965 to that in 1968?
Keep it short and to the point. 0.84. What is the ratio of the Value (constant 2005 US$) in Korea (Republic) in 1965 to that in 1969?
Your answer should be compact. 0.7. What is the ratio of the Value (constant 2005 US$) of Malaysia in 1965 to that in 1969?
Offer a very short reply. 0.87. What is the ratio of the Value (constant 2005 US$) in Philippines in 1965 to that in 1969?
Your answer should be very brief. 0.79. What is the ratio of the Value (constant 2005 US$) in Korea (Republic) in 1966 to that in 1967?
Your answer should be compact. 0.92. What is the ratio of the Value (constant 2005 US$) in Malaysia in 1966 to that in 1967?
Offer a terse response. 0.99. What is the ratio of the Value (constant 2005 US$) in Philippines in 1966 to that in 1967?
Keep it short and to the point. 0.9. What is the ratio of the Value (constant 2005 US$) in Korea (Republic) in 1966 to that in 1968?
Offer a very short reply. 0.84. What is the ratio of the Value (constant 2005 US$) of Malaysia in 1966 to that in 1968?
Provide a succinct answer. 0.99. What is the ratio of the Value (constant 2005 US$) of Philippines in 1966 to that in 1968?
Offer a very short reply. 0.84. What is the ratio of the Value (constant 2005 US$) of Korea (Republic) in 1966 to that in 1969?
Offer a very short reply. 0.77. What is the ratio of the Value (constant 2005 US$) in Malaysia in 1966 to that in 1969?
Make the answer very short. 0.96. What is the ratio of the Value (constant 2005 US$) in Philippines in 1966 to that in 1969?
Give a very brief answer. 0.79. What is the ratio of the Value (constant 2005 US$) in Korea (Republic) in 1967 to that in 1968?
Provide a succinct answer. 0.91. What is the ratio of the Value (constant 2005 US$) of Malaysia in 1967 to that in 1968?
Provide a succinct answer. 1. What is the ratio of the Value (constant 2005 US$) of Philippines in 1967 to that in 1968?
Keep it short and to the point. 0.93. What is the ratio of the Value (constant 2005 US$) of Korea (Republic) in 1967 to that in 1969?
Your answer should be very brief. 0.83. What is the ratio of the Value (constant 2005 US$) in Malaysia in 1967 to that in 1969?
Give a very brief answer. 0.97. What is the ratio of the Value (constant 2005 US$) of Philippines in 1967 to that in 1969?
Offer a terse response. 0.88. What is the ratio of the Value (constant 2005 US$) of Korea (Republic) in 1968 to that in 1969?
Give a very brief answer. 0.91. What is the ratio of the Value (constant 2005 US$) in Malaysia in 1968 to that in 1969?
Your answer should be compact. 0.97. What is the ratio of the Value (constant 2005 US$) in Philippines in 1968 to that in 1969?
Offer a very short reply. 0.94. What is the difference between the highest and the second highest Value (constant 2005 US$) of Korea (Republic)?
Your answer should be very brief. 1.54e+09. What is the difference between the highest and the second highest Value (constant 2005 US$) in Malaysia?
Keep it short and to the point. 3.63e+07. What is the difference between the highest and the second highest Value (constant 2005 US$) in Philippines?
Your response must be concise. 1.85e+08. What is the difference between the highest and the lowest Value (constant 2005 US$) of Korea (Republic)?
Your answer should be very brief. 6.21e+09. What is the difference between the highest and the lowest Value (constant 2005 US$) in Malaysia?
Your answer should be very brief. 5.26e+08. What is the difference between the highest and the lowest Value (constant 2005 US$) of Philippines?
Keep it short and to the point. 1.05e+09. 